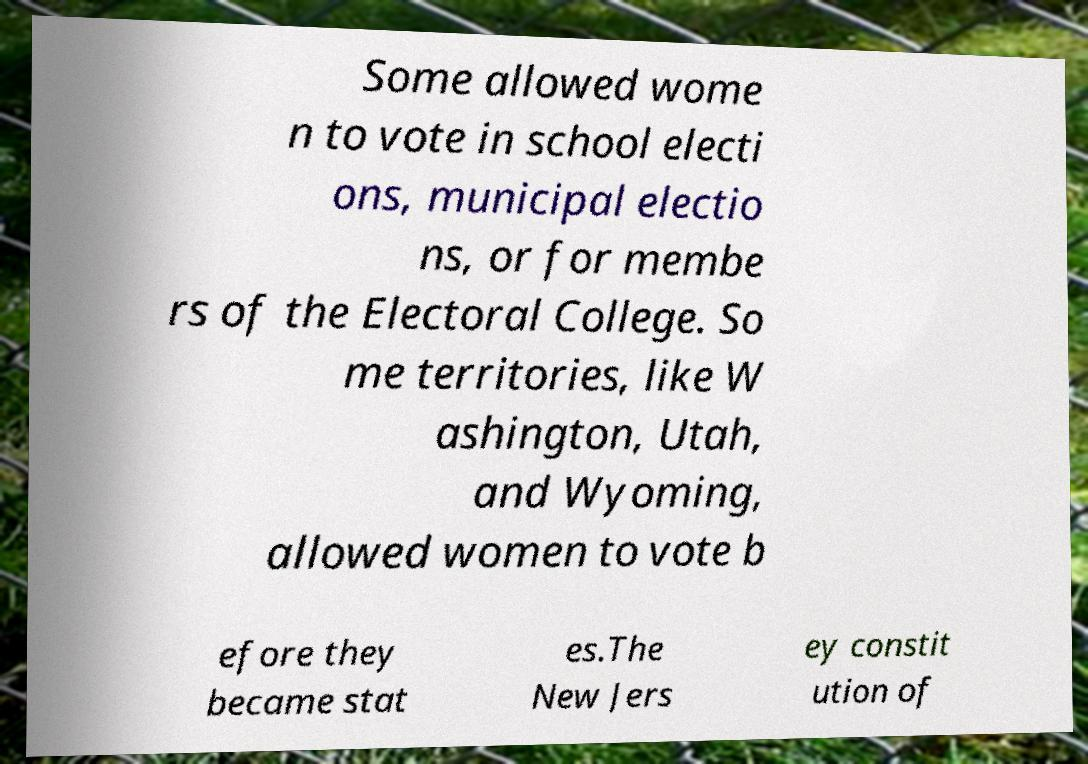For documentation purposes, I need the text within this image transcribed. Could you provide that? Some allowed wome n to vote in school electi ons, municipal electio ns, or for membe rs of the Electoral College. So me territories, like W ashington, Utah, and Wyoming, allowed women to vote b efore they became stat es.The New Jers ey constit ution of 